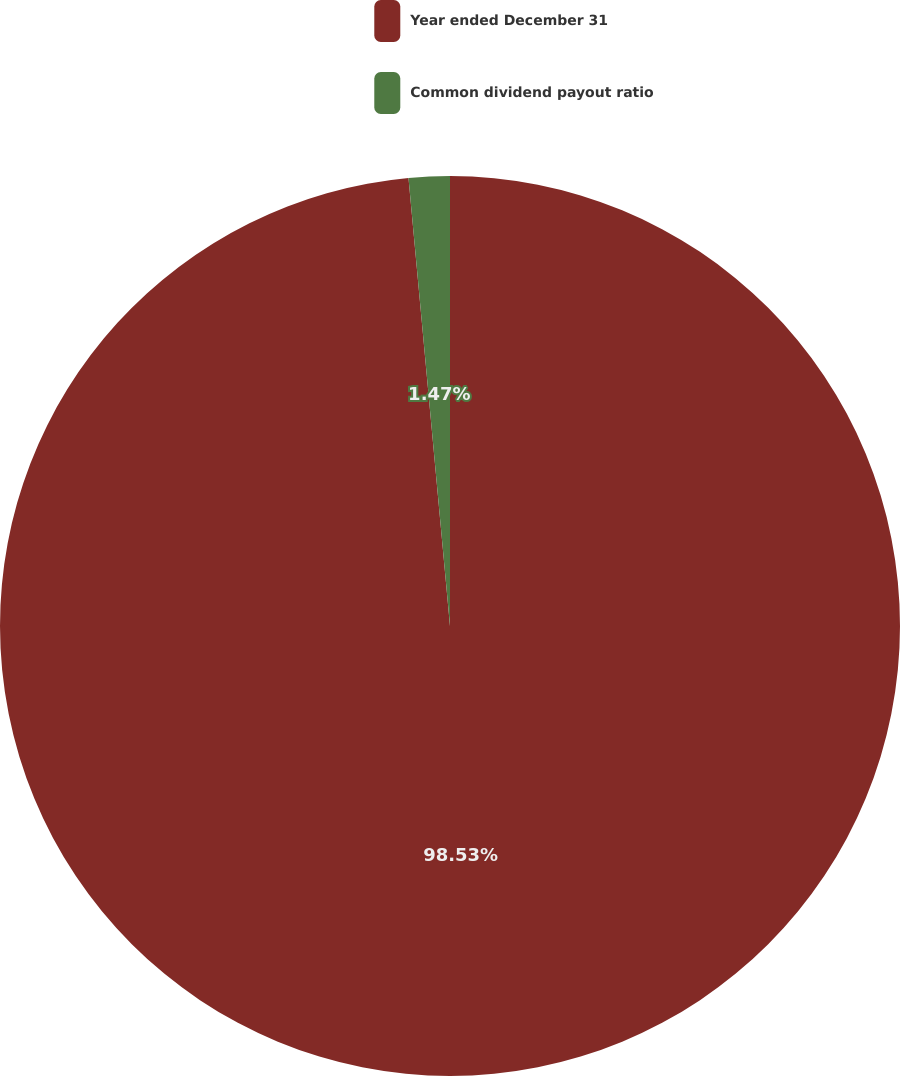Convert chart. <chart><loc_0><loc_0><loc_500><loc_500><pie_chart><fcel>Year ended December 31<fcel>Common dividend payout ratio<nl><fcel>98.53%<fcel>1.47%<nl></chart> 